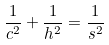<formula> <loc_0><loc_0><loc_500><loc_500>\frac { 1 } { c ^ { 2 } } + \frac { 1 } { h ^ { 2 } } = \frac { 1 } { s ^ { 2 } }</formula> 